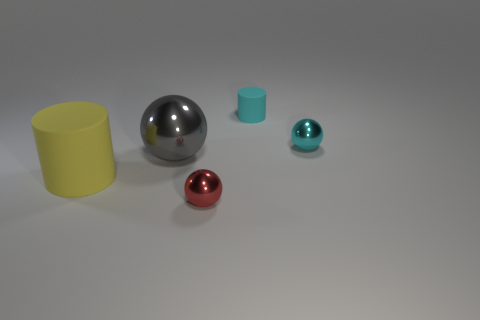There is another thing that is the same color as the tiny matte thing; what is its shape?
Provide a short and direct response. Sphere. What is the size of the metallic object that is left of the tiny object that is in front of the yellow cylinder?
Make the answer very short. Large. Do the cyan rubber thing and the gray sphere have the same size?
Give a very brief answer. No. Are there any small cylinders on the left side of the cylinder that is in front of the big gray ball in front of the tiny cyan sphere?
Your answer should be very brief. No. The cyan rubber object is what size?
Give a very brief answer. Small. How many other gray metallic spheres have the same size as the gray sphere?
Provide a succinct answer. 0. There is a tiny red thing that is the same shape as the tiny cyan metallic object; what is its material?
Keep it short and to the point. Metal. What is the shape of the metallic thing that is both to the left of the small cyan cylinder and to the right of the gray metallic sphere?
Your response must be concise. Sphere. The matte object right of the large yellow cylinder has what shape?
Provide a short and direct response. Cylinder. How many tiny objects are behind the big cylinder and in front of the cyan matte thing?
Ensure brevity in your answer.  1. 